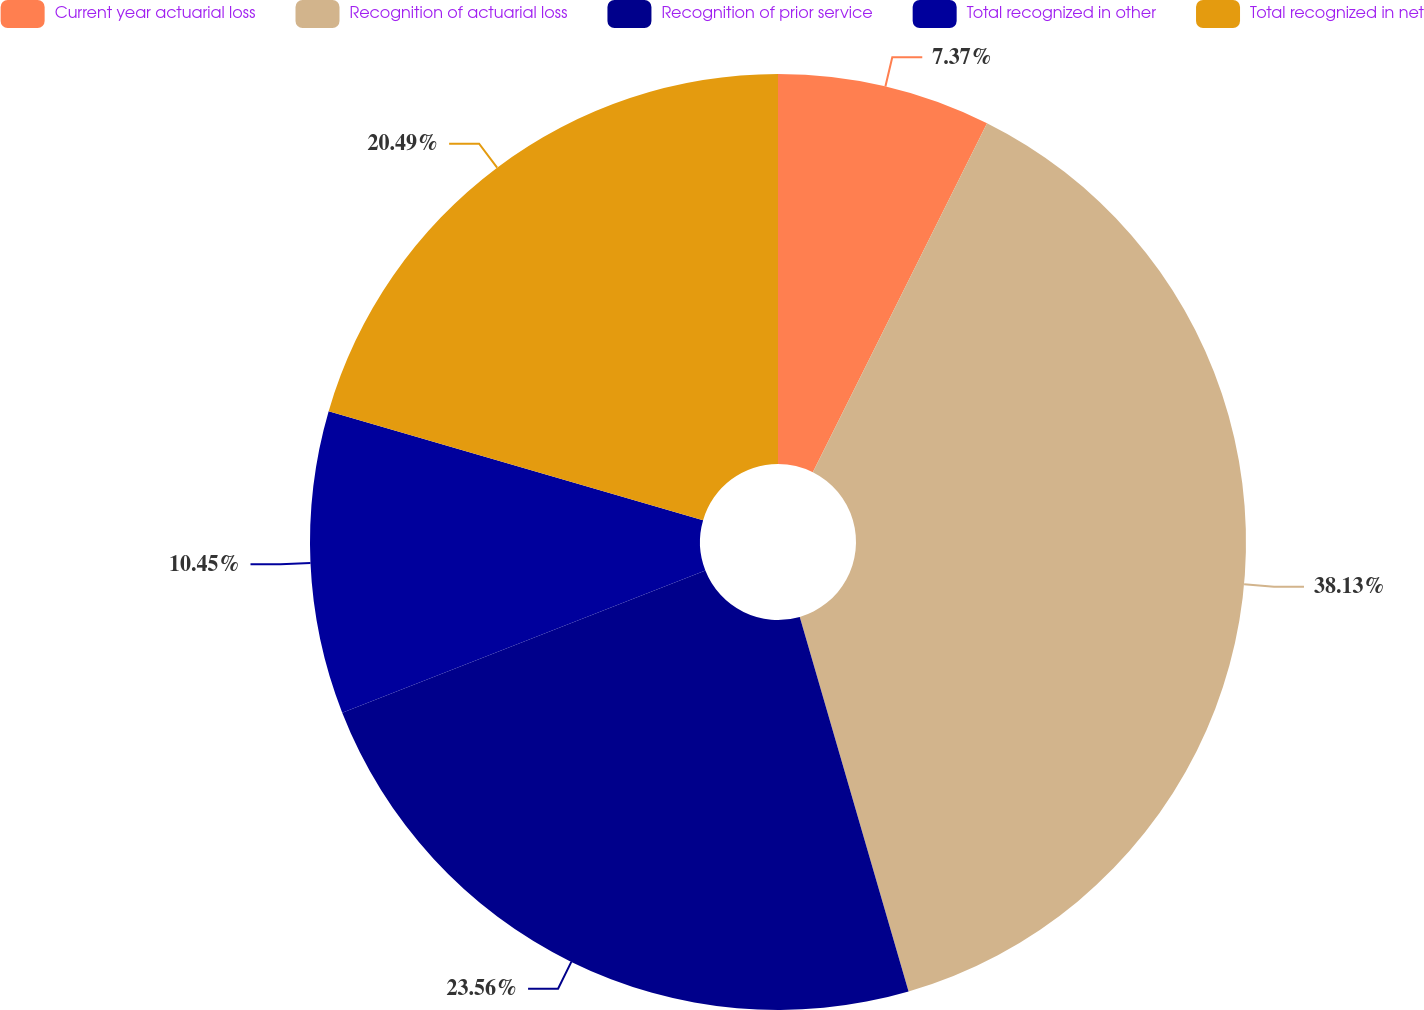<chart> <loc_0><loc_0><loc_500><loc_500><pie_chart><fcel>Current year actuarial loss<fcel>Recognition of actuarial loss<fcel>Recognition of prior service<fcel>Total recognized in other<fcel>Total recognized in net<nl><fcel>7.37%<fcel>38.13%<fcel>23.56%<fcel>10.45%<fcel>20.49%<nl></chart> 